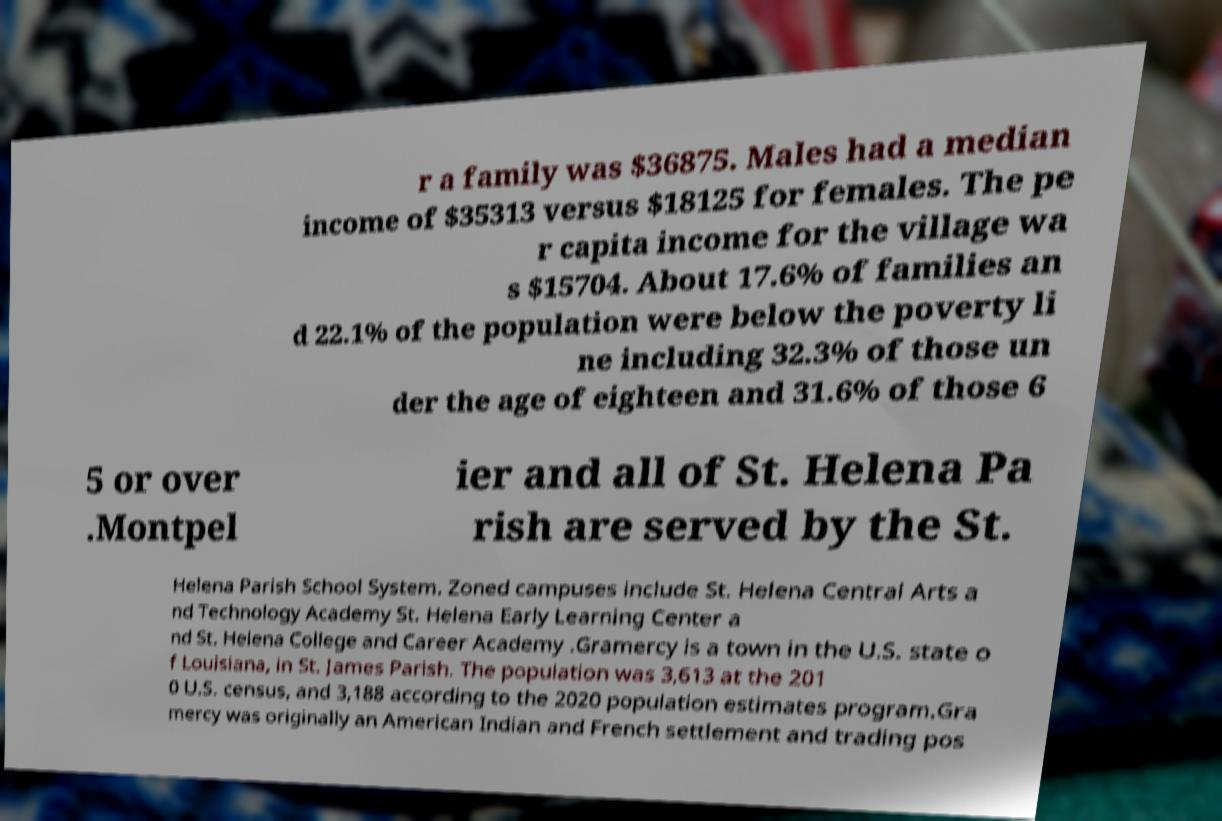I need the written content from this picture converted into text. Can you do that? r a family was $36875. Males had a median income of $35313 versus $18125 for females. The pe r capita income for the village wa s $15704. About 17.6% of families an d 22.1% of the population were below the poverty li ne including 32.3% of those un der the age of eighteen and 31.6% of those 6 5 or over .Montpel ier and all of St. Helena Pa rish are served by the St. Helena Parish School System. Zoned campuses include St. Helena Central Arts a nd Technology Academy St. Helena Early Learning Center a nd St. Helena College and Career Academy .Gramercy is a town in the U.S. state o f Louisiana, in St. James Parish. The population was 3,613 at the 201 0 U.S. census, and 3,188 according to the 2020 population estimates program.Gra mercy was originally an American Indian and French settlement and trading pos 